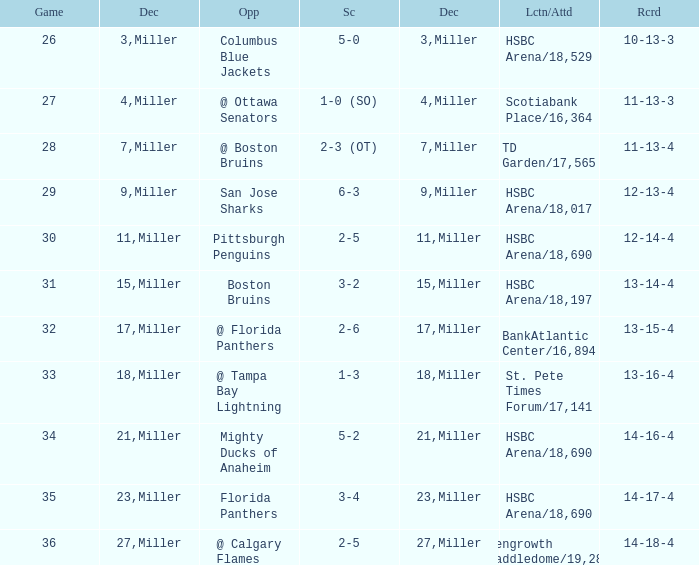Name the opponent for record 10-13-3 Columbus Blue Jackets. 